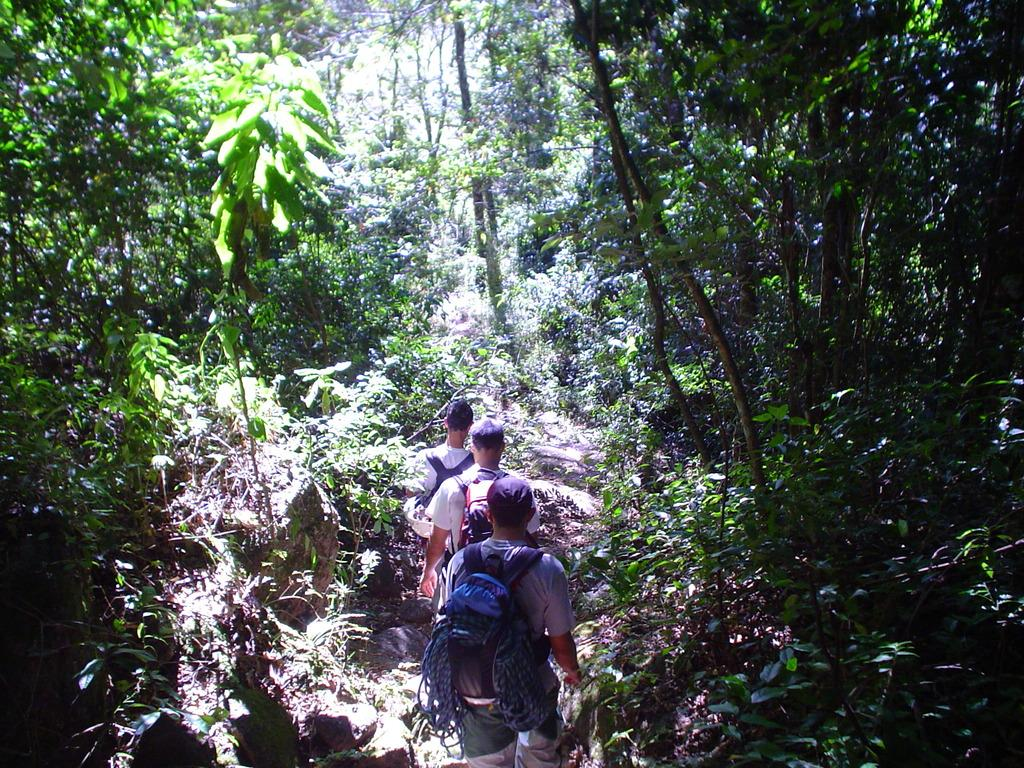How many people are in the image? There are 3 people in the image. What are the people doing in the image? The people are walking in the image. On what type of terrain are the people walking? They are on a rocky path. What type of vegetation can be seen in the image? Bushes and trees are visible in the image. What type of pen is being used by the person in the image? There is no pen present in the image; the people are walking on a rocky path. 